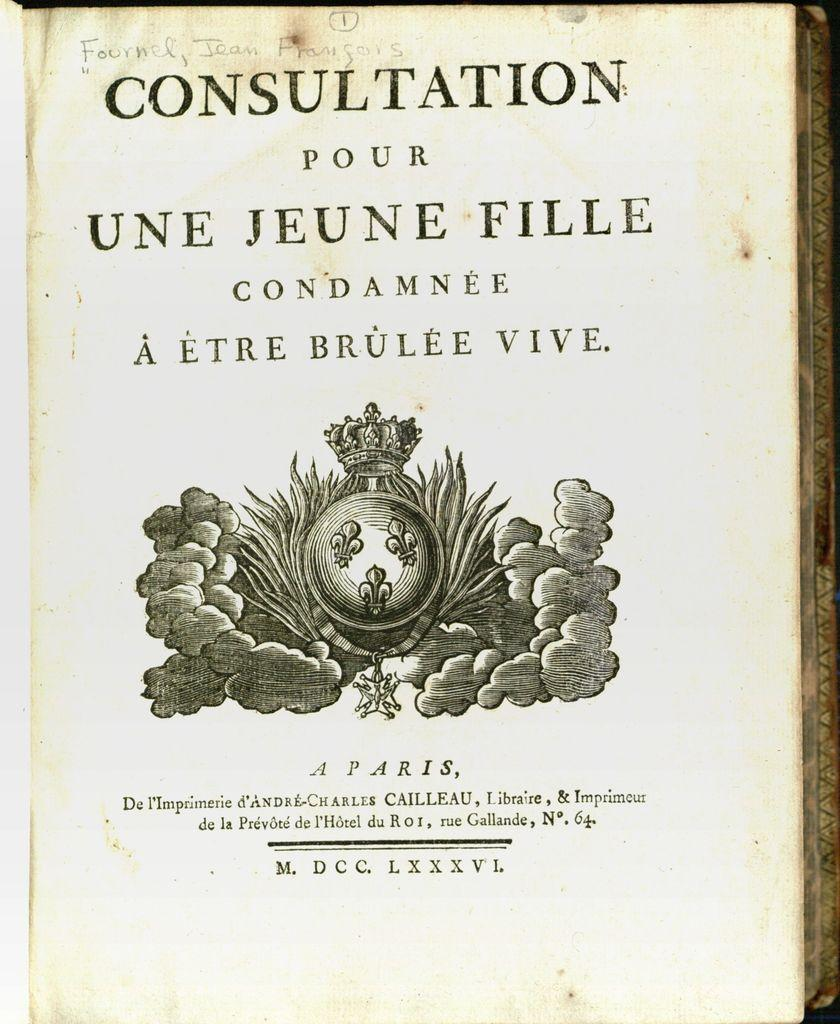<image>
Create a compact narrative representing the image presented. A book is open to the title page which says Consultation Pour Une Jeune Fille. 